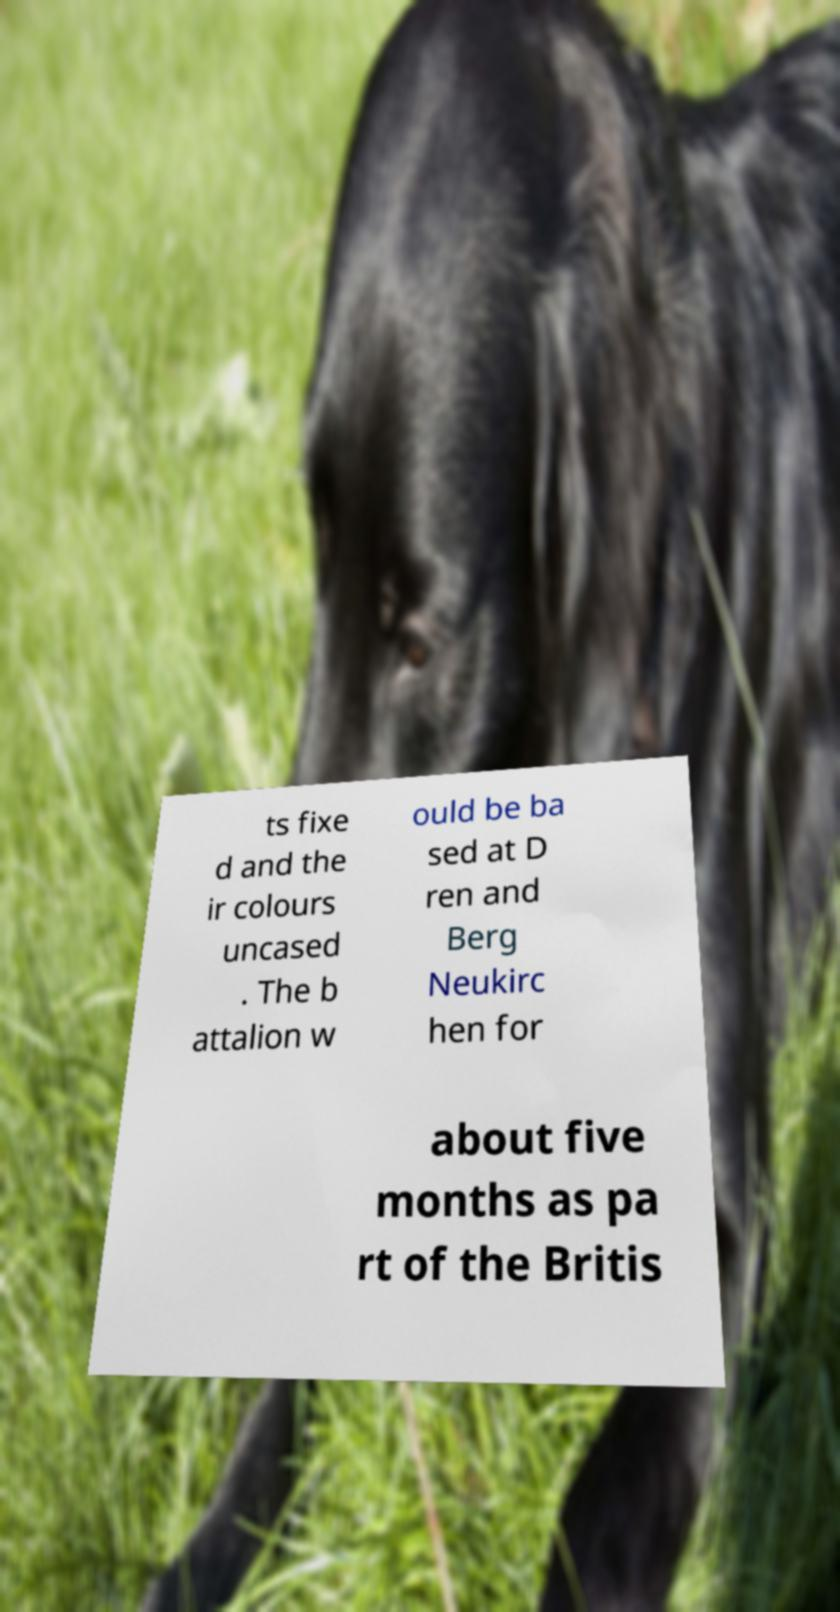Can you read and provide the text displayed in the image?This photo seems to have some interesting text. Can you extract and type it out for me? ts fixe d and the ir colours uncased . The b attalion w ould be ba sed at D ren and Berg Neukirc hen for about five months as pa rt of the Britis 